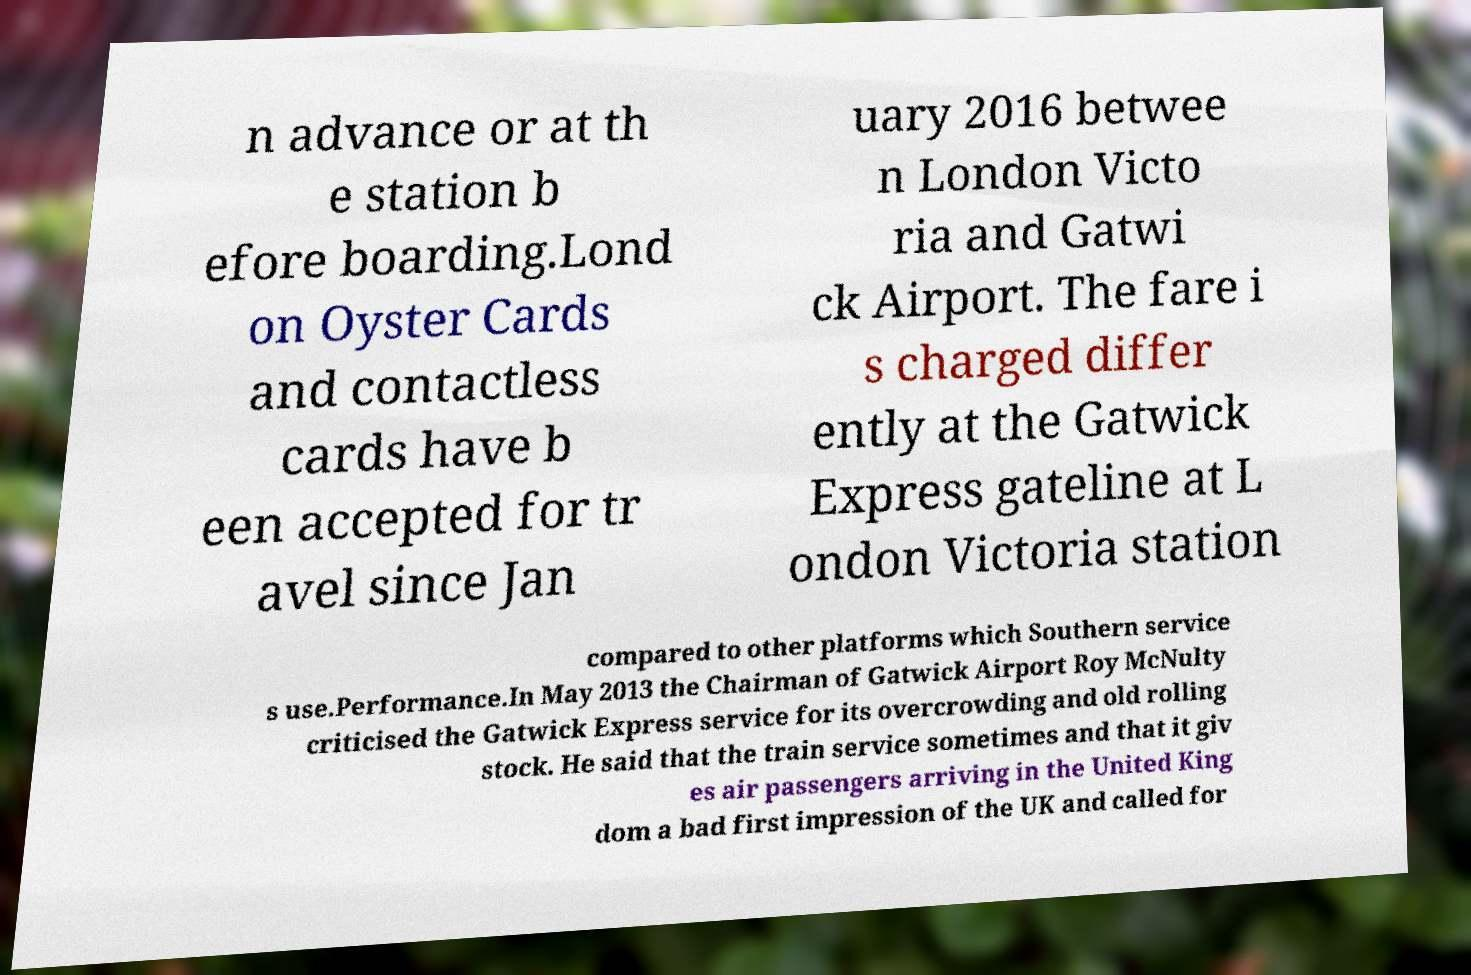Can you accurately transcribe the text from the provided image for me? n advance or at th e station b efore boarding.Lond on Oyster Cards and contactless cards have b een accepted for tr avel since Jan uary 2016 betwee n London Victo ria and Gatwi ck Airport. The fare i s charged differ ently at the Gatwick Express gateline at L ondon Victoria station compared to other platforms which Southern service s use.Performance.In May 2013 the Chairman of Gatwick Airport Roy McNulty criticised the Gatwick Express service for its overcrowding and old rolling stock. He said that the train service sometimes and that it giv es air passengers arriving in the United King dom a bad first impression of the UK and called for 